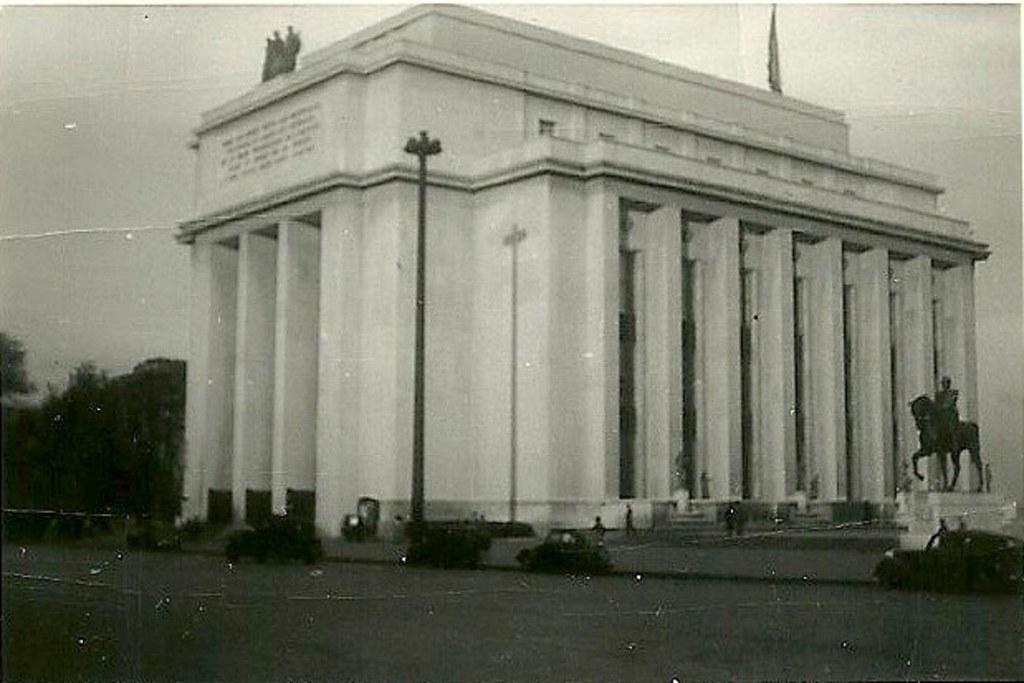Describe this image in one or two sentences. This is a black and white image. In the center of the image there is a building. There is a pole. There is a statue to the right side of the image. At the top of the image there is sky. To the left side of the image there are trees. At the bottom of the image there is road. 